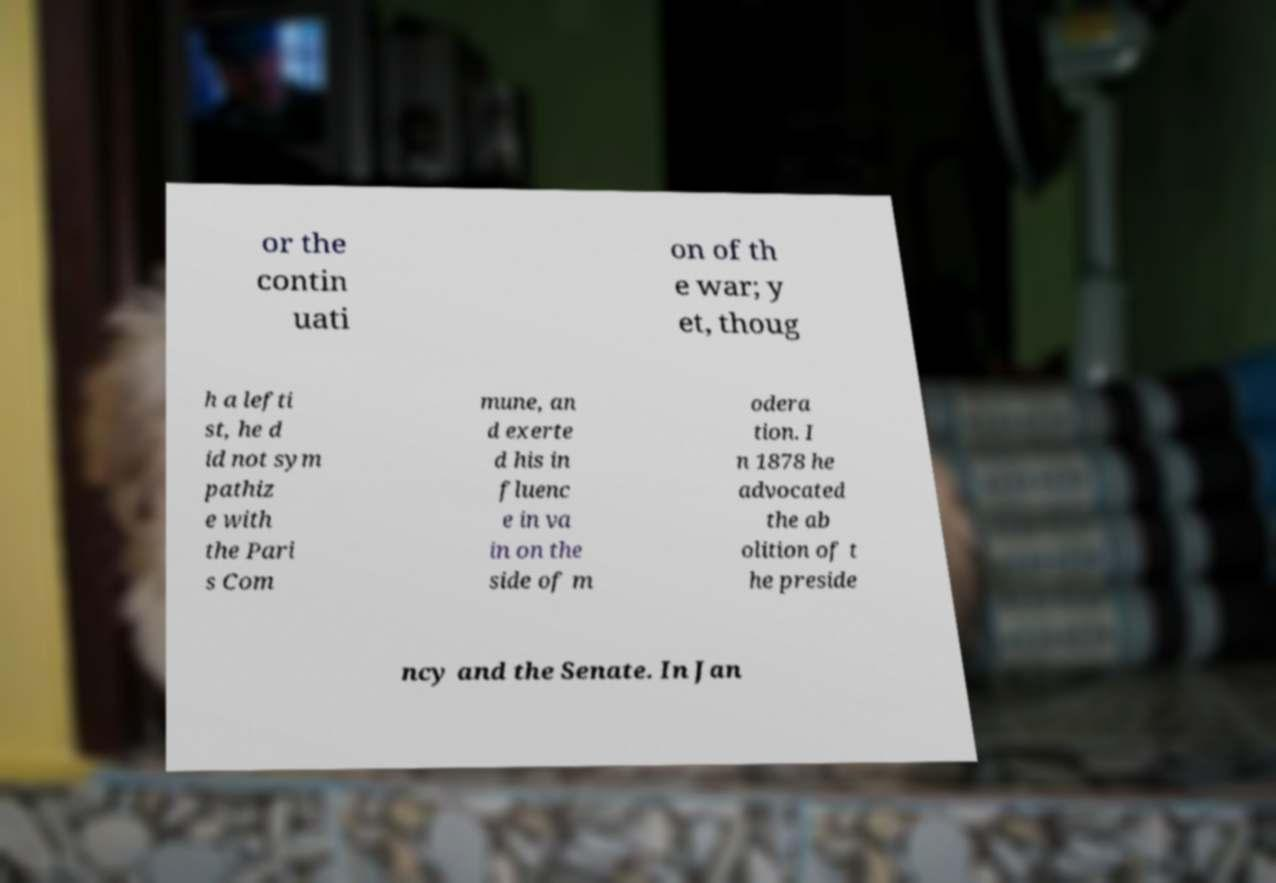Can you read and provide the text displayed in the image?This photo seems to have some interesting text. Can you extract and type it out for me? or the contin uati on of th e war; y et, thoug h a lefti st, he d id not sym pathiz e with the Pari s Com mune, an d exerte d his in fluenc e in va in on the side of m odera tion. I n 1878 he advocated the ab olition of t he preside ncy and the Senate. In Jan 